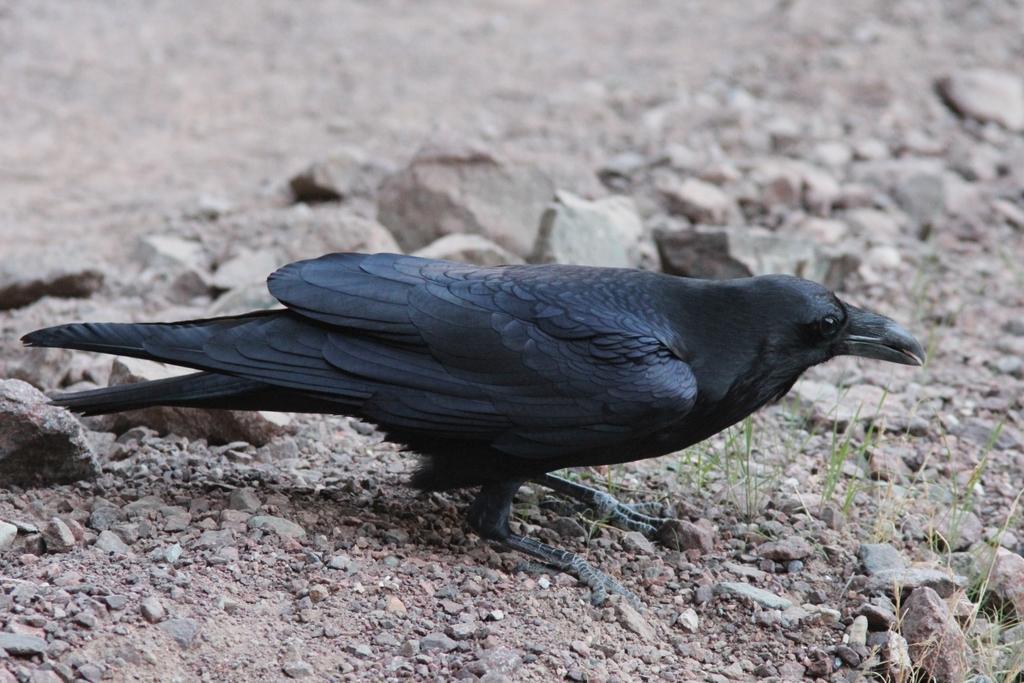Can you describe this image briefly? In this image I can see a bird which is in gray color. Background I can see few stones. 